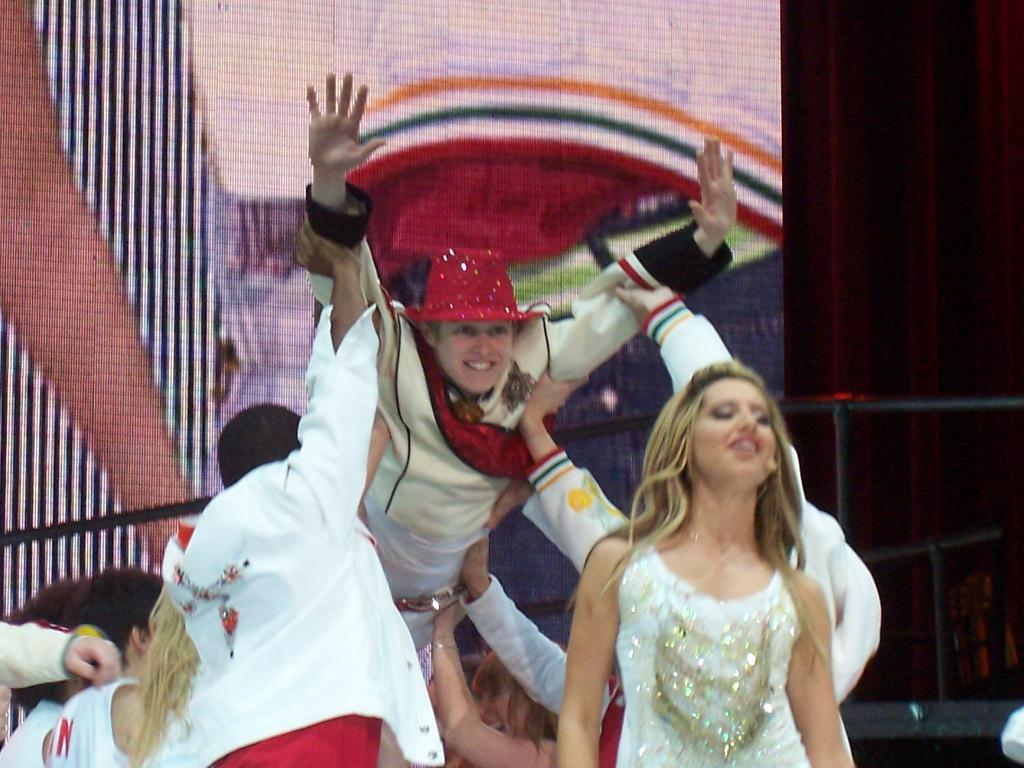What is the main subject of the image? The main subject of the image is a group of people. What are the people wearing in the image? The people are wearing white color dress. What else can be seen in the image besides the group of people? There is a banner in the image. What is the color of the background in the image? The background of the image is dark. What type of brass instrument is being played by the group of people in the image? There is no brass instrument visible in the image; the people are wearing white color dress. What is the opinion of the group of people about the event in the image? The image does not provide any information about the group's opinion; it only shows their clothing and the presence of a banner. 